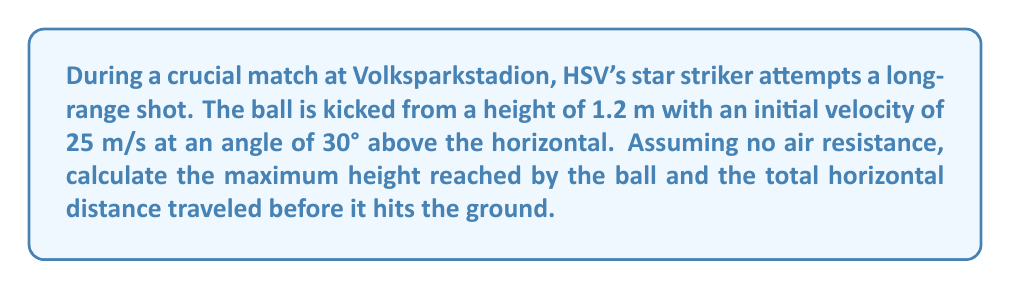Solve this math problem. Let's approach this problem step-by-step using projectile motion equations:

1) First, let's define our variables:
   $v_0 = 25$ m/s (initial velocity)
   $\theta = 30°$ (angle of projection)
   $h_0 = 1.2$ m (initial height)
   $g = 9.8$ m/s² (acceleration due to gravity)

2) To find the maximum height, we need to calculate the vertical component of velocity:
   $v_{0y} = v_0 \sin(\theta) = 25 \sin(30°) = 12.5$ m/s

3) The time to reach maximum height is given by:
   $t_{max} = \frac{v_{0y}}{g} = \frac{12.5}{9.8} = 1.276$ s

4) The maximum height is calculated using:
   $$h_{max} = h_0 + v_{0y}t_{max} - \frac{1}{2}gt_{max}^2$$
   $$h_{max} = 1.2 + 12.5(1.276) - \frac{1}{2}(9.8)(1.276)^2 = 9.19$ m

5) For the total horizontal distance, we need the total time of flight. The ball reaches the ground when its height is zero:
   $$0 = h_0 + v_{0y}t - \frac{1}{2}gt^2$$

6) Solving this quadratic equation:
   $t = \frac{v_{0y} + \sqrt{v_{0y}^2 + 2gh_0}}{g} = \frac{12.5 + \sqrt{12.5^2 + 2(9.8)(1.2)}}{9.8} = 2.63$ s

7) The horizontal component of velocity is constant:
   $v_{0x} = v_0 \cos(\theta) = 25 \cos(30°) = 21.65$ m/s

8) The total horizontal distance is:
   $$d = v_{0x}t = 21.65(2.63) = 56.94$ m
Answer: Maximum height: 9.19 m; Horizontal distance: 56.94 m 